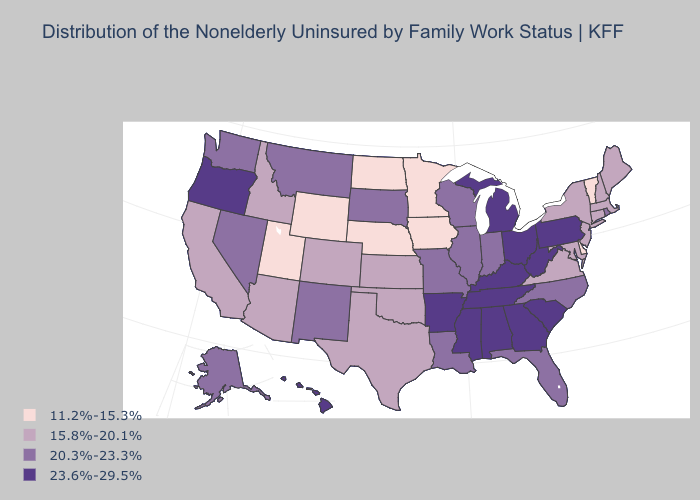Does South Carolina have a lower value than New Mexico?
Keep it brief. No. Does the first symbol in the legend represent the smallest category?
Short answer required. Yes. Does Connecticut have the highest value in the USA?
Give a very brief answer. No. What is the value of Louisiana?
Be succinct. 20.3%-23.3%. Name the states that have a value in the range 15.8%-20.1%?
Write a very short answer. Arizona, California, Colorado, Connecticut, Idaho, Kansas, Maine, Maryland, Massachusetts, New Hampshire, New Jersey, New York, Oklahoma, Texas, Virginia. What is the value of Vermont?
Quick response, please. 11.2%-15.3%. Name the states that have a value in the range 11.2%-15.3%?
Keep it brief. Delaware, Iowa, Minnesota, Nebraska, North Dakota, Utah, Vermont, Wyoming. Does Vermont have the lowest value in the USA?
Answer briefly. Yes. Name the states that have a value in the range 15.8%-20.1%?
Give a very brief answer. Arizona, California, Colorado, Connecticut, Idaho, Kansas, Maine, Maryland, Massachusetts, New Hampshire, New Jersey, New York, Oklahoma, Texas, Virginia. Does Wisconsin have the same value as Florida?
Be succinct. Yes. What is the lowest value in states that border New York?
Give a very brief answer. 11.2%-15.3%. Name the states that have a value in the range 11.2%-15.3%?
Short answer required. Delaware, Iowa, Minnesota, Nebraska, North Dakota, Utah, Vermont, Wyoming. Does West Virginia have a lower value than Hawaii?
Be succinct. No. Name the states that have a value in the range 15.8%-20.1%?
Quick response, please. Arizona, California, Colorado, Connecticut, Idaho, Kansas, Maine, Maryland, Massachusetts, New Hampshire, New Jersey, New York, Oklahoma, Texas, Virginia. Does New Jersey have the highest value in the Northeast?
Give a very brief answer. No. 